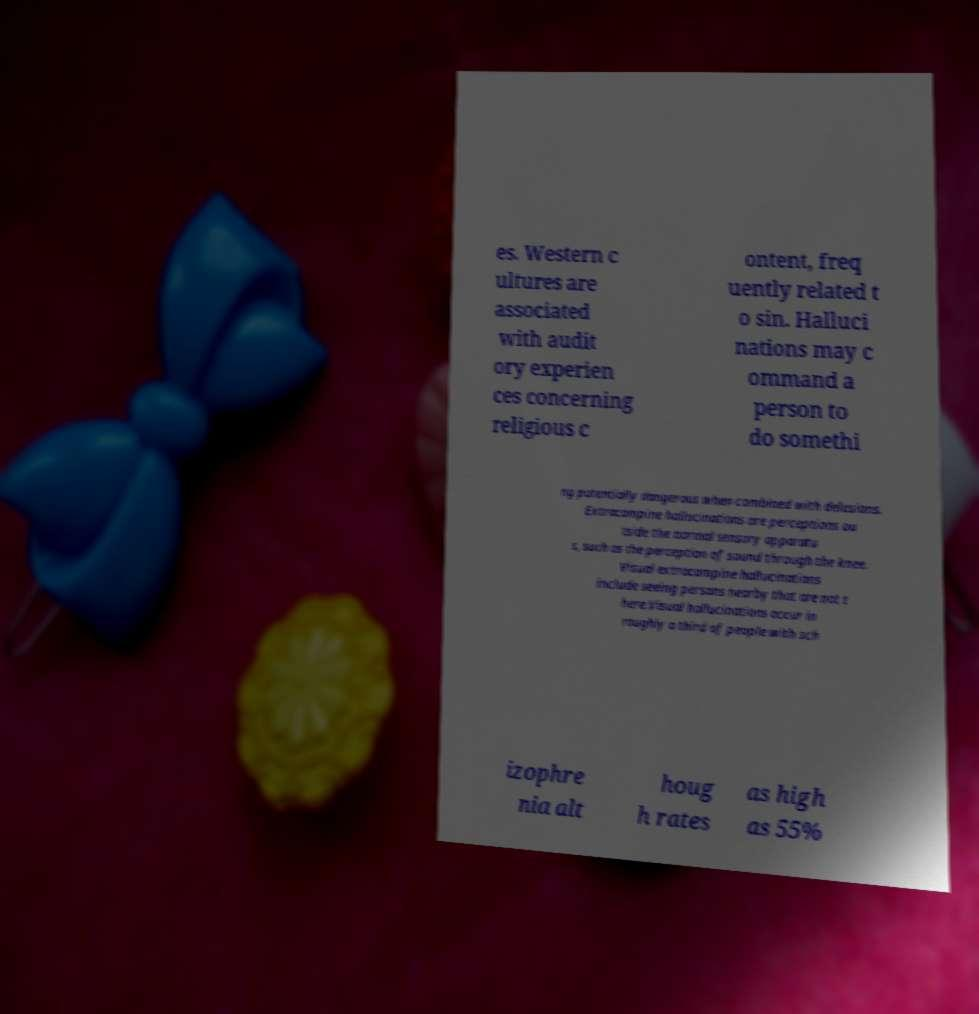What messages or text are displayed in this image? I need them in a readable, typed format. es. Western c ultures are associated with audit ory experien ces concerning religious c ontent, freq uently related t o sin. Halluci nations may c ommand a person to do somethi ng potentially dangerous when combined with delusions. Extracampine hallucinations are perceptions ou tside the normal sensory apparatu s, such as the perception of sound through the knee. Visual extracampine hallucinations include seeing persons nearby that are not t here.Visual hallucinations occur in roughly a third of people with sch izophre nia alt houg h rates as high as 55% 